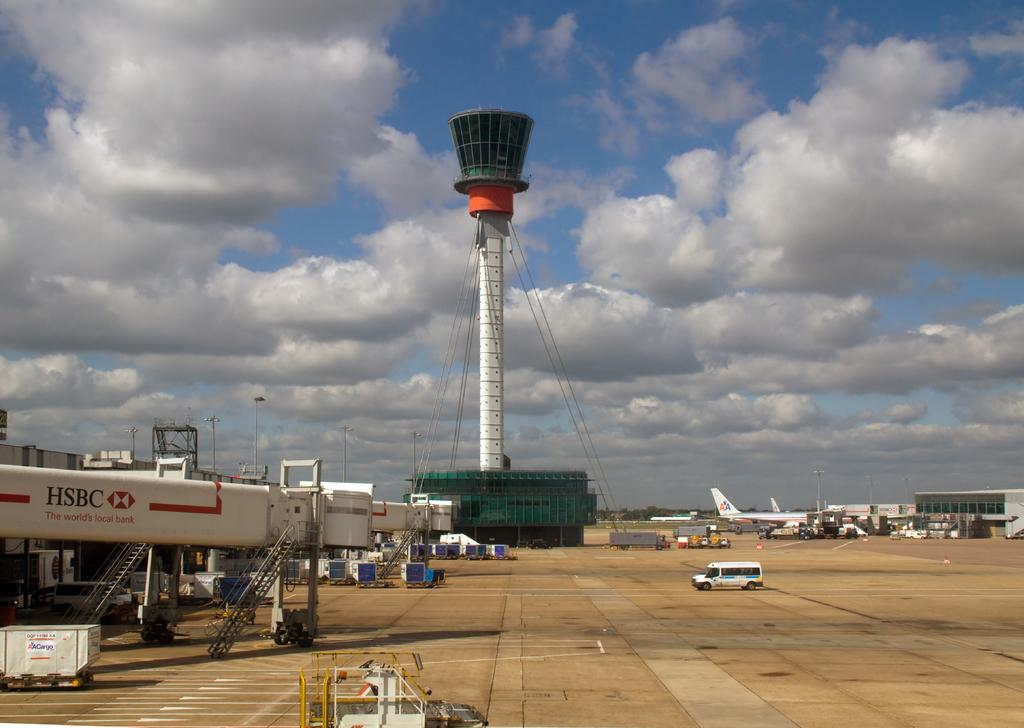<image>
Describe the image concisely. The HSBC bank name is visible on several pieces of airport equipment. 